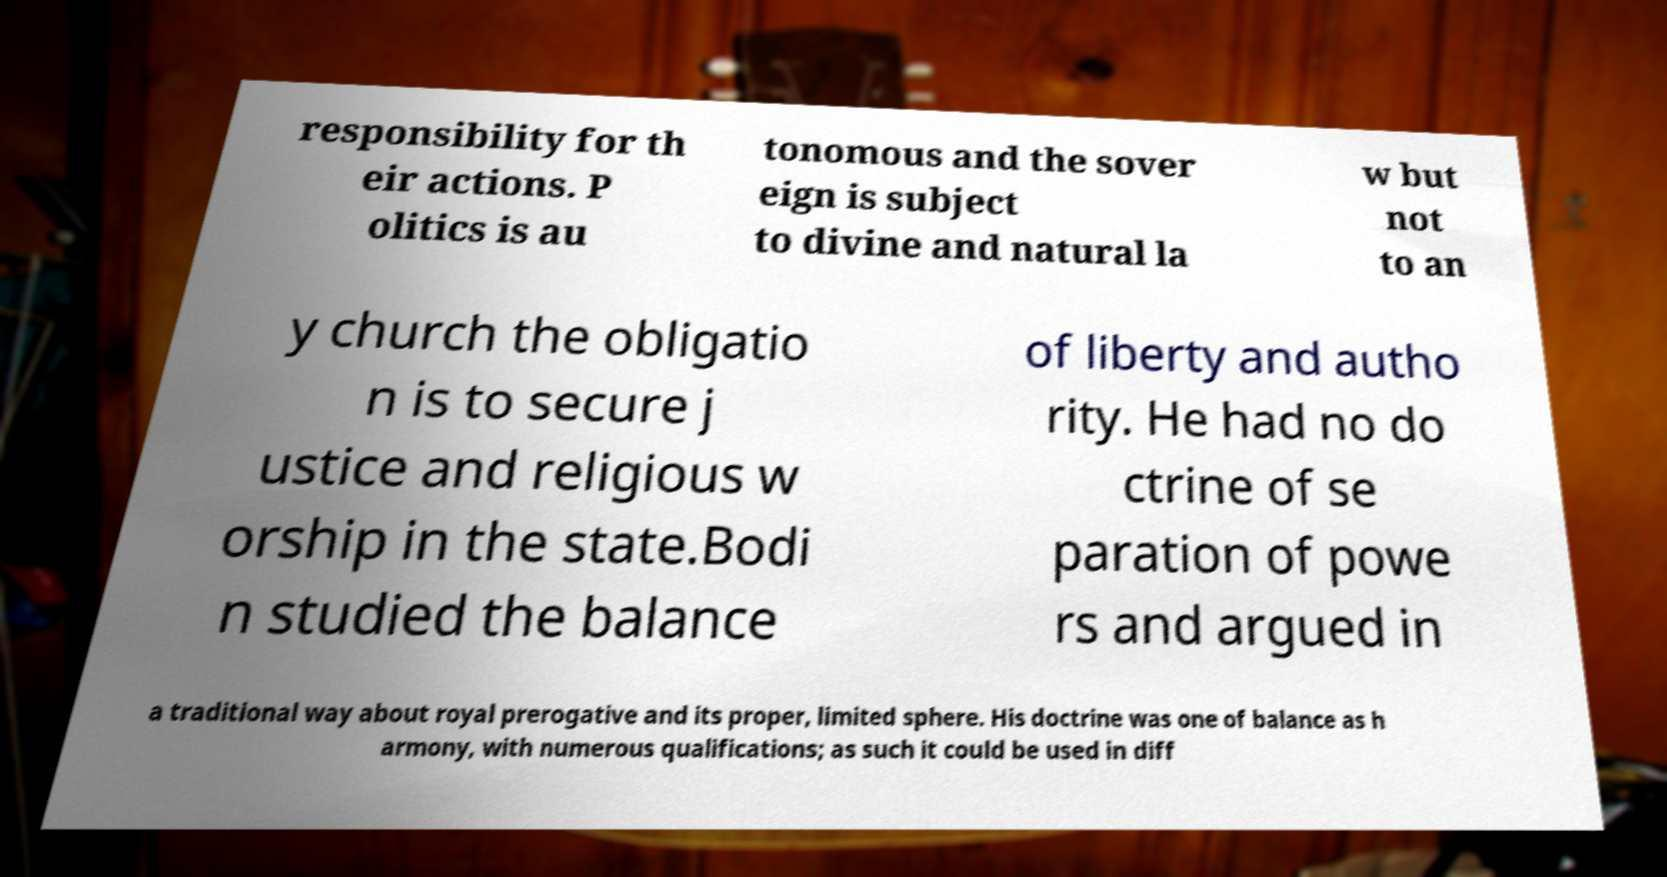Please read and relay the text visible in this image. What does it say? responsibility for th eir actions. P olitics is au tonomous and the sover eign is subject to divine and natural la w but not to an y church the obligatio n is to secure j ustice and religious w orship in the state.Bodi n studied the balance of liberty and autho rity. He had no do ctrine of se paration of powe rs and argued in a traditional way about royal prerogative and its proper, limited sphere. His doctrine was one of balance as h armony, with numerous qualifications; as such it could be used in diff 